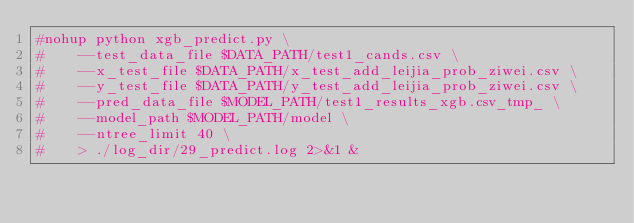<code> <loc_0><loc_0><loc_500><loc_500><_Bash_>#nohup python xgb_predict.py \
#    --test_data_file $DATA_PATH/test1_cands.csv \
#    --x_test_file $DATA_PATH/x_test_add_leijia_prob_ziwei.csv \
#    --y_test_file $DATA_PATH/y_test_add_leijia_prob_ziwei.csv \
#    --pred_data_file $MODEL_PATH/test1_results_xgb.csv_tmp_ \
#    --model_path $MODEL_PATH/model \
#    --ntree_limit 40 \
#    > ./log_dir/29_predict.log 2>&1 &</code> 